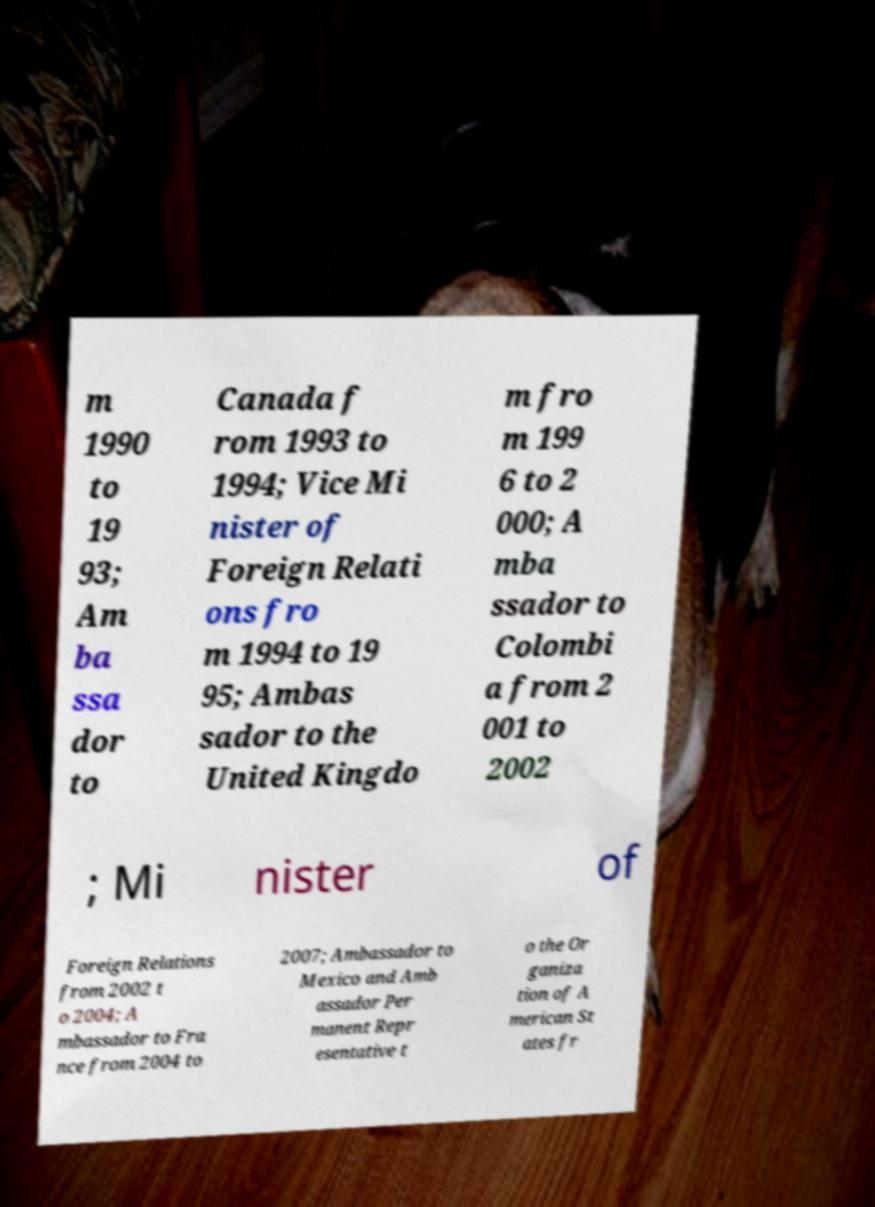Could you extract and type out the text from this image? m 1990 to 19 93; Am ba ssa dor to Canada f rom 1993 to 1994; Vice Mi nister of Foreign Relati ons fro m 1994 to 19 95; Ambas sador to the United Kingdo m fro m 199 6 to 2 000; A mba ssador to Colombi a from 2 001 to 2002 ; Mi nister of Foreign Relations from 2002 t o 2004; A mbassador to Fra nce from 2004 to 2007; Ambassador to Mexico and Amb assador Per manent Repr esentative t o the Or ganiza tion of A merican St ates fr 